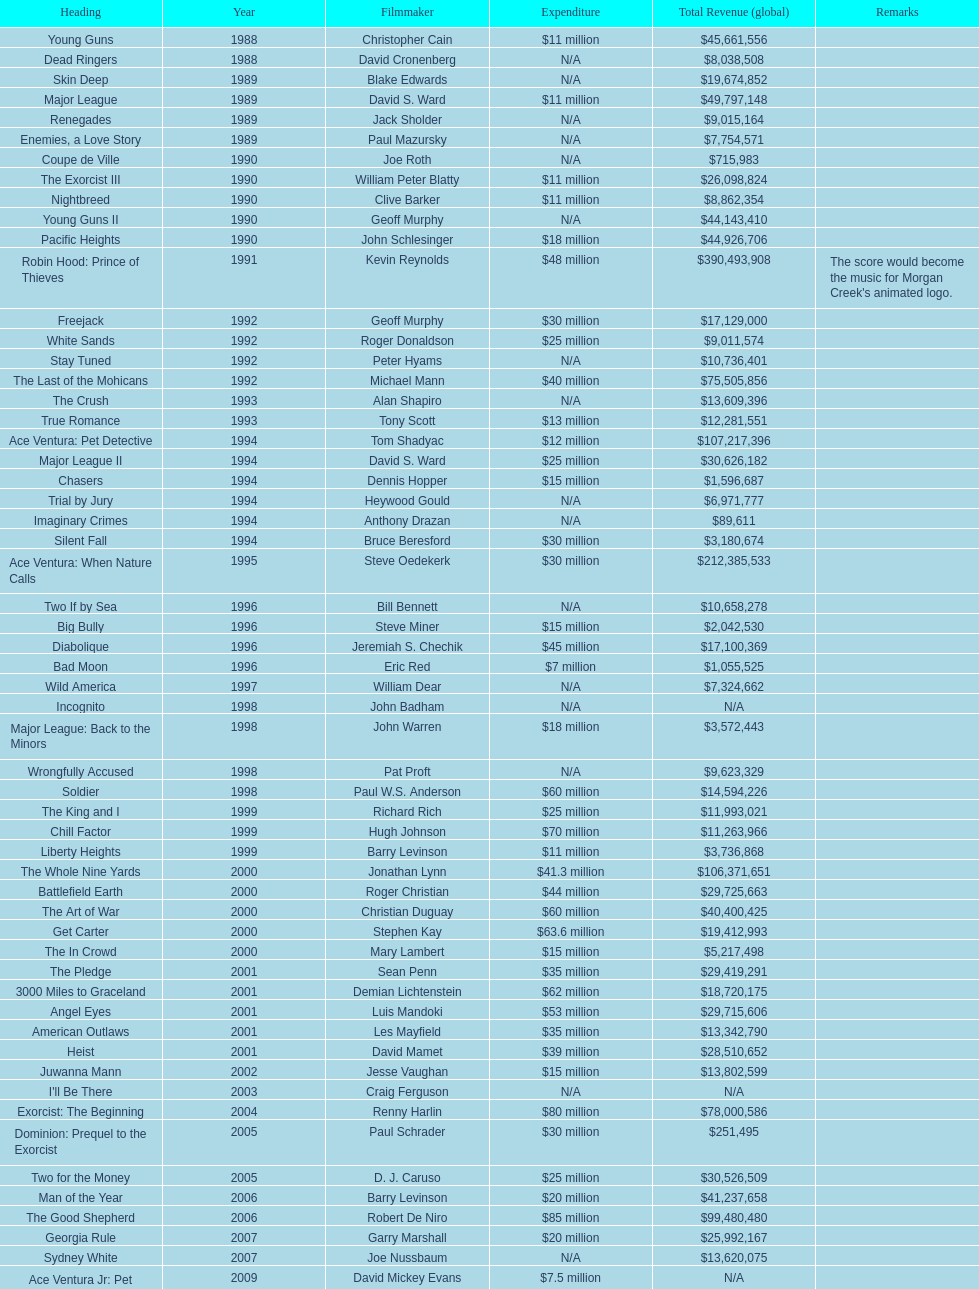What is the quantity of films helmed by david s. ward? 2. 